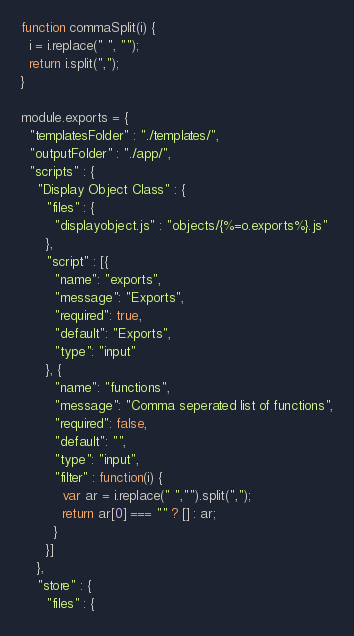Convert code to text. <code><loc_0><loc_0><loc_500><loc_500><_JavaScript_>function commaSplit(i) {
  i = i.replace(" ", "");
  return i.split(",");
}

module.exports = {
  "templatesFolder" : "./templates/",
  "outputFolder" : "./app/",
  "scripts" : {
    "Display Object Class" : {
      "files" : {
        "displayobject.js" : "objects/{%=o.exports%}.js"
      },
      "script" : [{
        "name": "exports",
        "message": "Exports",
        "required": true,
        "default": "Exports",
        "type": "input"
      }, {
        "name": "functions",
        "message": "Comma seperated list of functions",
        "required": false,
        "default": "",
        "type": "input",
        "filter" : function(i) {
          var ar = i.replace(" ","").split(",");
          return ar[0] === "" ? [] : ar;
        }
      }]
    },
    "store" : {
      "files" : {</code> 